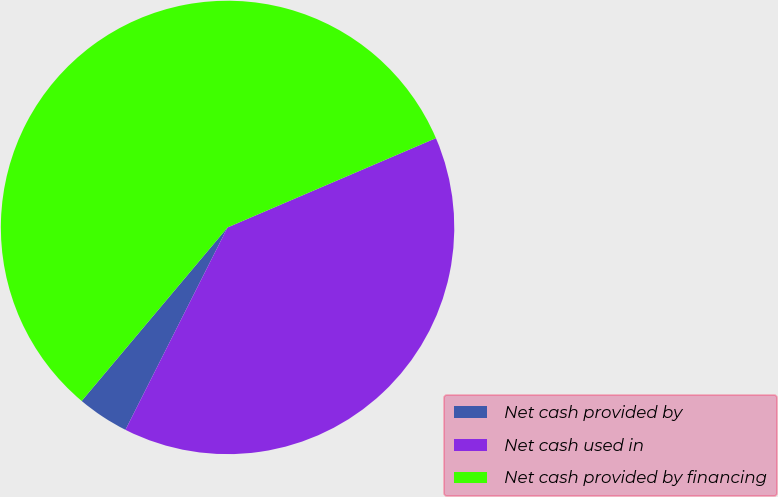Convert chart. <chart><loc_0><loc_0><loc_500><loc_500><pie_chart><fcel>Net cash provided by<fcel>Net cash used in<fcel>Net cash provided by financing<nl><fcel>3.69%<fcel>38.88%<fcel>57.43%<nl></chart> 